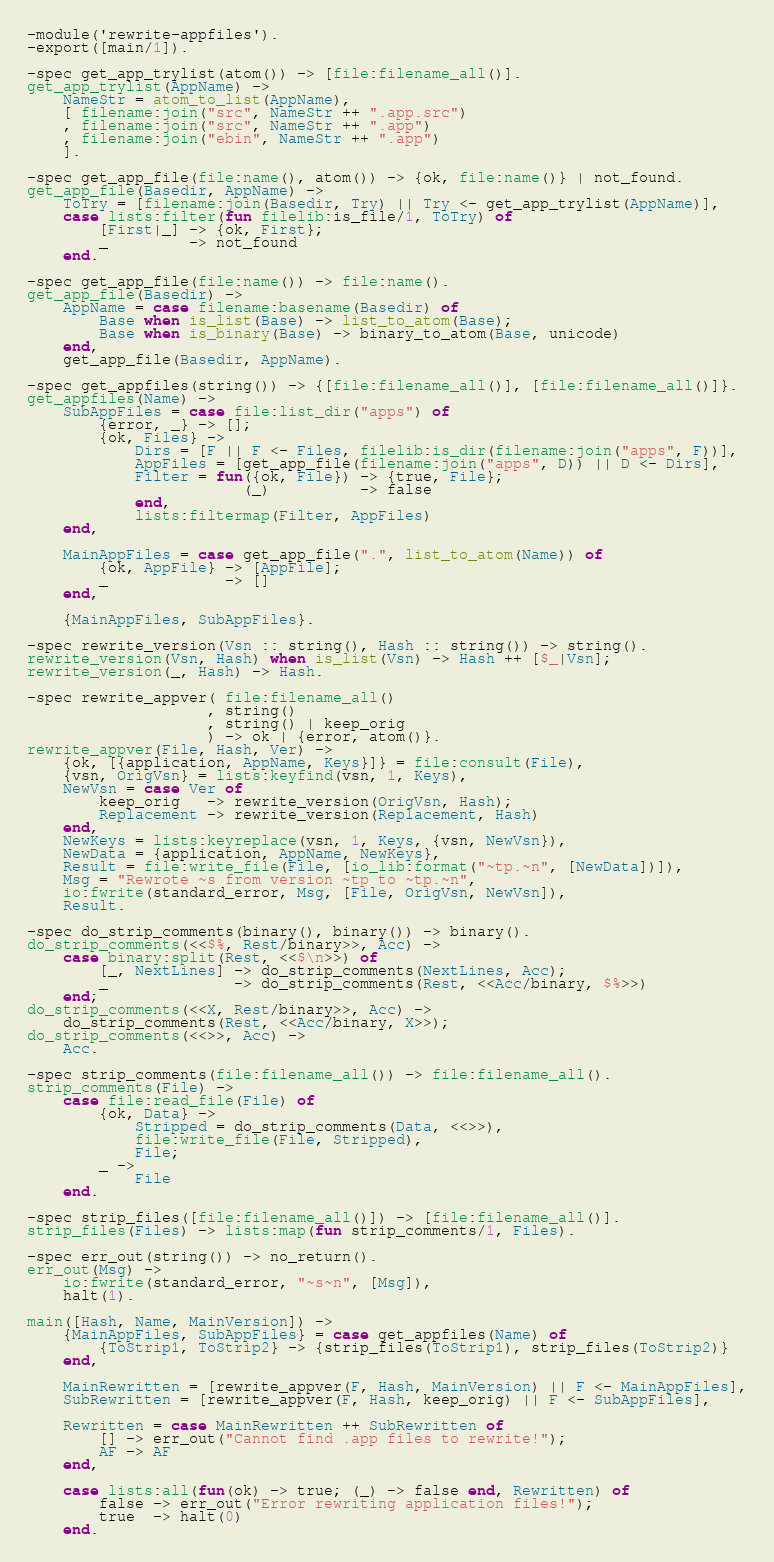<code> <loc_0><loc_0><loc_500><loc_500><_Erlang_>-module('rewrite-appfiles').
-export([main/1]).

-spec get_app_trylist(atom()) -> [file:filename_all()].
get_app_trylist(AppName) ->
    NameStr = atom_to_list(AppName),
    [ filename:join("src", NameStr ++ ".app.src")
    , filename:join("src", NameStr ++ ".app")
    , filename:join("ebin", NameStr ++ ".app")
    ].

-spec get_app_file(file:name(), atom()) -> {ok, file:name()} | not_found.
get_app_file(Basedir, AppName) ->
    ToTry = [filename:join(Basedir, Try) || Try <- get_app_trylist(AppName)],
    case lists:filter(fun filelib:is_file/1, ToTry) of
        [First|_] -> {ok, First};
        _         -> not_found
    end.

-spec get_app_file(file:name()) -> file:name().
get_app_file(Basedir) ->
    AppName = case filename:basename(Basedir) of
        Base when is_list(Base) -> list_to_atom(Base);
        Base when is_binary(Base) -> binary_to_atom(Base, unicode)
    end,
    get_app_file(Basedir, AppName).

-spec get_appfiles(string()) -> {[file:filename_all()], [file:filename_all()]}.
get_appfiles(Name) ->
    SubAppFiles = case file:list_dir("apps") of
        {error, _} -> [];
        {ok, Files} ->
            Dirs = [F || F <- Files, filelib:is_dir(filename:join("apps", F))],
            AppFiles = [get_app_file(filename:join("apps", D)) || D <- Dirs],
            Filter = fun({ok, File}) -> {true, File};
                        (_)          -> false
            end,
            lists:filtermap(Filter, AppFiles)
    end,

    MainAppFiles = case get_app_file(".", list_to_atom(Name)) of
        {ok, AppFile} -> [AppFile];
        _             -> []
    end,

    {MainAppFiles, SubAppFiles}.

-spec rewrite_version(Vsn :: string(), Hash :: string()) -> string().
rewrite_version(Vsn, Hash) when is_list(Vsn) -> Hash ++ [$_|Vsn];
rewrite_version(_, Hash) -> Hash.

-spec rewrite_appver( file:filename_all()
                    , string()
                    , string() | keep_orig
                    ) -> ok | {error, atom()}.
rewrite_appver(File, Hash, Ver) ->
    {ok, [{application, AppName, Keys}]} = file:consult(File),
    {vsn, OrigVsn} = lists:keyfind(vsn, 1, Keys),
    NewVsn = case Ver of
        keep_orig   -> rewrite_version(OrigVsn, Hash);
        Replacement -> rewrite_version(Replacement, Hash)
    end,
    NewKeys = lists:keyreplace(vsn, 1, Keys, {vsn, NewVsn}),
    NewData = {application, AppName, NewKeys},
    Result = file:write_file(File, [io_lib:format("~tp.~n", [NewData])]),
    Msg = "Rewrote ~s from version ~tp to ~tp.~n",
    io:fwrite(standard_error, Msg, [File, OrigVsn, NewVsn]),
    Result.

-spec do_strip_comments(binary(), binary()) -> binary().
do_strip_comments(<<$%, Rest/binary>>, Acc) ->
    case binary:split(Rest, <<$\n>>) of
        [_, NextLines] -> do_strip_comments(NextLines, Acc);
        _              -> do_strip_comments(Rest, <<Acc/binary, $%>>)
    end;
do_strip_comments(<<X, Rest/binary>>, Acc) ->
    do_strip_comments(Rest, <<Acc/binary, X>>);
do_strip_comments(<<>>, Acc) ->
    Acc.

-spec strip_comments(file:filename_all()) -> file:filename_all().
strip_comments(File) ->
    case file:read_file(File) of
        {ok, Data} ->
            Stripped = do_strip_comments(Data, <<>>),
            file:write_file(File, Stripped),
            File;
        _ ->
            File
    end.

-spec strip_files([file:filename_all()]) -> [file:filename_all()].
strip_files(Files) -> lists:map(fun strip_comments/1, Files).

-spec err_out(string()) -> no_return().
err_out(Msg) ->
    io:fwrite(standard_error, "~s~n", [Msg]),
    halt(1).

main([Hash, Name, MainVersion]) ->
    {MainAppFiles, SubAppFiles} = case get_appfiles(Name) of
        {ToStrip1, ToStrip2} -> {strip_files(ToStrip1), strip_files(ToStrip2)}
    end,

    MainRewritten = [rewrite_appver(F, Hash, MainVersion) || F <- MainAppFiles],
    SubRewritten = [rewrite_appver(F, Hash, keep_orig) || F <- SubAppFiles],

    Rewritten = case MainRewritten ++ SubRewritten of
        [] -> err_out("Cannot find .app files to rewrite!");
        AF -> AF
    end,

    case lists:all(fun(ok) -> true; (_) -> false end, Rewritten) of
        false -> err_out("Error rewriting application files!");
        true  -> halt(0)
    end.
</code> 